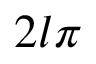Convert formula to latex. <formula><loc_0><loc_0><loc_500><loc_500>2 l \pi</formula> 